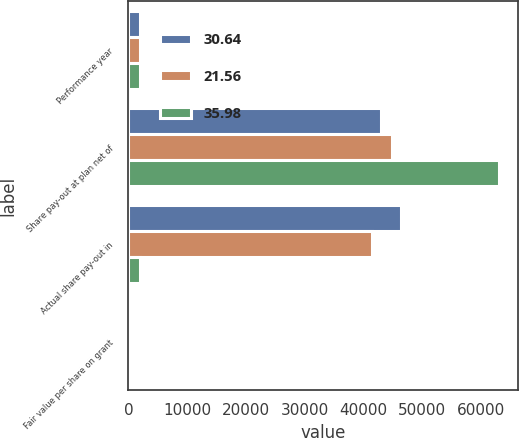Convert chart to OTSL. <chart><loc_0><loc_0><loc_500><loc_500><stacked_bar_chart><ecel><fcel>Performance year<fcel>Share pay-out at plan net of<fcel>Actual share pay-out in<fcel>Fair value per share on grant<nl><fcel>30.64<fcel>2013<fcel>42908<fcel>46340<fcel>35.98<nl><fcel>21.56<fcel>2012<fcel>44843<fcel>41481<fcel>30.64<nl><fcel>35.98<fcel>2011<fcel>63102<fcel>2013<fcel>21.56<nl></chart> 